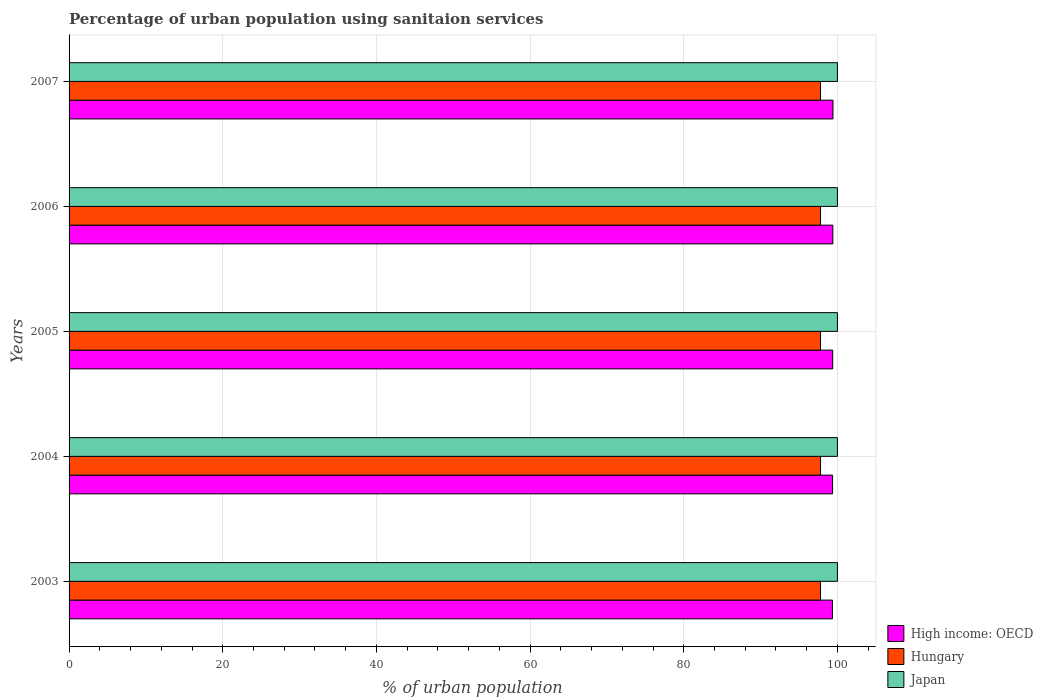How many different coloured bars are there?
Provide a succinct answer. 3. Are the number of bars per tick equal to the number of legend labels?
Make the answer very short. Yes. What is the percentage of urban population using sanitaion services in High income: OECD in 2003?
Make the answer very short. 99.35. Across all years, what is the maximum percentage of urban population using sanitaion services in Japan?
Your answer should be very brief. 100. Across all years, what is the minimum percentage of urban population using sanitaion services in Hungary?
Keep it short and to the point. 97.8. In which year was the percentage of urban population using sanitaion services in Japan minimum?
Offer a terse response. 2003. What is the total percentage of urban population using sanitaion services in Hungary in the graph?
Your answer should be compact. 489. What is the difference between the percentage of urban population using sanitaion services in Hungary in 2004 and the percentage of urban population using sanitaion services in Japan in 2003?
Offer a terse response. -2.2. In the year 2006, what is the difference between the percentage of urban population using sanitaion services in High income: OECD and percentage of urban population using sanitaion services in Hungary?
Provide a short and direct response. 1.6. Is the percentage of urban population using sanitaion services in High income: OECD in 2005 less than that in 2007?
Provide a short and direct response. Yes. What is the difference between the highest and the second highest percentage of urban population using sanitaion services in High income: OECD?
Offer a terse response. 0.02. What is the difference between the highest and the lowest percentage of urban population using sanitaion services in High income: OECD?
Your answer should be very brief. 0.07. In how many years, is the percentage of urban population using sanitaion services in Japan greater than the average percentage of urban population using sanitaion services in Japan taken over all years?
Offer a terse response. 0. What does the 2nd bar from the top in 2007 represents?
Your answer should be compact. Hungary. What does the 1st bar from the bottom in 2004 represents?
Offer a terse response. High income: OECD. Is it the case that in every year, the sum of the percentage of urban population using sanitaion services in High income: OECD and percentage of urban population using sanitaion services in Hungary is greater than the percentage of urban population using sanitaion services in Japan?
Provide a short and direct response. Yes. How many bars are there?
Offer a very short reply. 15. Are all the bars in the graph horizontal?
Your answer should be compact. Yes. Does the graph contain any zero values?
Your response must be concise. No. How many legend labels are there?
Your answer should be very brief. 3. What is the title of the graph?
Your response must be concise. Percentage of urban population using sanitaion services. Does "Belgium" appear as one of the legend labels in the graph?
Make the answer very short. No. What is the label or title of the X-axis?
Ensure brevity in your answer.  % of urban population. What is the label or title of the Y-axis?
Your answer should be very brief. Years. What is the % of urban population of High income: OECD in 2003?
Offer a terse response. 99.35. What is the % of urban population of Hungary in 2003?
Give a very brief answer. 97.8. What is the % of urban population in High income: OECD in 2004?
Give a very brief answer. 99.37. What is the % of urban population in Hungary in 2004?
Provide a succinct answer. 97.8. What is the % of urban population of Japan in 2004?
Offer a terse response. 100. What is the % of urban population in High income: OECD in 2005?
Provide a short and direct response. 99.39. What is the % of urban population of Hungary in 2005?
Offer a very short reply. 97.8. What is the % of urban population of Japan in 2005?
Keep it short and to the point. 100. What is the % of urban population of High income: OECD in 2006?
Offer a terse response. 99.4. What is the % of urban population in Hungary in 2006?
Your answer should be compact. 97.8. What is the % of urban population in High income: OECD in 2007?
Provide a succinct answer. 99.42. What is the % of urban population in Hungary in 2007?
Your answer should be very brief. 97.8. Across all years, what is the maximum % of urban population in High income: OECD?
Offer a terse response. 99.42. Across all years, what is the maximum % of urban population of Hungary?
Offer a terse response. 97.8. Across all years, what is the maximum % of urban population of Japan?
Your answer should be compact. 100. Across all years, what is the minimum % of urban population in High income: OECD?
Your answer should be very brief. 99.35. Across all years, what is the minimum % of urban population of Hungary?
Provide a succinct answer. 97.8. Across all years, what is the minimum % of urban population in Japan?
Your answer should be very brief. 100. What is the total % of urban population of High income: OECD in the graph?
Offer a terse response. 496.93. What is the total % of urban population of Hungary in the graph?
Provide a short and direct response. 489. What is the difference between the % of urban population in High income: OECD in 2003 and that in 2004?
Keep it short and to the point. -0.02. What is the difference between the % of urban population in High income: OECD in 2003 and that in 2005?
Your response must be concise. -0.04. What is the difference between the % of urban population of Hungary in 2003 and that in 2005?
Offer a terse response. 0. What is the difference between the % of urban population of High income: OECD in 2003 and that in 2006?
Your answer should be compact. -0.05. What is the difference between the % of urban population of Hungary in 2003 and that in 2006?
Offer a very short reply. 0. What is the difference between the % of urban population in High income: OECD in 2003 and that in 2007?
Keep it short and to the point. -0.07. What is the difference between the % of urban population in Hungary in 2003 and that in 2007?
Provide a short and direct response. 0. What is the difference between the % of urban population in Japan in 2003 and that in 2007?
Ensure brevity in your answer.  0. What is the difference between the % of urban population in High income: OECD in 2004 and that in 2005?
Provide a short and direct response. -0.02. What is the difference between the % of urban population of Hungary in 2004 and that in 2005?
Offer a very short reply. 0. What is the difference between the % of urban population in Japan in 2004 and that in 2005?
Your response must be concise. 0. What is the difference between the % of urban population in High income: OECD in 2004 and that in 2006?
Provide a succinct answer. -0.04. What is the difference between the % of urban population of Japan in 2004 and that in 2006?
Provide a succinct answer. 0. What is the difference between the % of urban population in High income: OECD in 2004 and that in 2007?
Keep it short and to the point. -0.05. What is the difference between the % of urban population in High income: OECD in 2005 and that in 2006?
Your answer should be very brief. -0.02. What is the difference between the % of urban population of Japan in 2005 and that in 2006?
Keep it short and to the point. 0. What is the difference between the % of urban population of High income: OECD in 2005 and that in 2007?
Ensure brevity in your answer.  -0.03. What is the difference between the % of urban population in Hungary in 2005 and that in 2007?
Offer a very short reply. 0. What is the difference between the % of urban population of High income: OECD in 2006 and that in 2007?
Make the answer very short. -0.02. What is the difference between the % of urban population in High income: OECD in 2003 and the % of urban population in Hungary in 2004?
Give a very brief answer. 1.55. What is the difference between the % of urban population of High income: OECD in 2003 and the % of urban population of Japan in 2004?
Give a very brief answer. -0.65. What is the difference between the % of urban population in Hungary in 2003 and the % of urban population in Japan in 2004?
Give a very brief answer. -2.2. What is the difference between the % of urban population of High income: OECD in 2003 and the % of urban population of Hungary in 2005?
Keep it short and to the point. 1.55. What is the difference between the % of urban population of High income: OECD in 2003 and the % of urban population of Japan in 2005?
Your answer should be very brief. -0.65. What is the difference between the % of urban population in Hungary in 2003 and the % of urban population in Japan in 2005?
Your response must be concise. -2.2. What is the difference between the % of urban population in High income: OECD in 2003 and the % of urban population in Hungary in 2006?
Your answer should be compact. 1.55. What is the difference between the % of urban population in High income: OECD in 2003 and the % of urban population in Japan in 2006?
Your answer should be very brief. -0.65. What is the difference between the % of urban population of Hungary in 2003 and the % of urban population of Japan in 2006?
Keep it short and to the point. -2.2. What is the difference between the % of urban population in High income: OECD in 2003 and the % of urban population in Hungary in 2007?
Keep it short and to the point. 1.55. What is the difference between the % of urban population of High income: OECD in 2003 and the % of urban population of Japan in 2007?
Offer a terse response. -0.65. What is the difference between the % of urban population of High income: OECD in 2004 and the % of urban population of Hungary in 2005?
Offer a very short reply. 1.57. What is the difference between the % of urban population of High income: OECD in 2004 and the % of urban population of Japan in 2005?
Provide a short and direct response. -0.63. What is the difference between the % of urban population in High income: OECD in 2004 and the % of urban population in Hungary in 2006?
Make the answer very short. 1.57. What is the difference between the % of urban population of High income: OECD in 2004 and the % of urban population of Japan in 2006?
Give a very brief answer. -0.63. What is the difference between the % of urban population in High income: OECD in 2004 and the % of urban population in Hungary in 2007?
Offer a very short reply. 1.57. What is the difference between the % of urban population of High income: OECD in 2004 and the % of urban population of Japan in 2007?
Your response must be concise. -0.63. What is the difference between the % of urban population of High income: OECD in 2005 and the % of urban population of Hungary in 2006?
Your answer should be compact. 1.59. What is the difference between the % of urban population in High income: OECD in 2005 and the % of urban population in Japan in 2006?
Give a very brief answer. -0.61. What is the difference between the % of urban population in Hungary in 2005 and the % of urban population in Japan in 2006?
Give a very brief answer. -2.2. What is the difference between the % of urban population in High income: OECD in 2005 and the % of urban population in Hungary in 2007?
Give a very brief answer. 1.59. What is the difference between the % of urban population in High income: OECD in 2005 and the % of urban population in Japan in 2007?
Your response must be concise. -0.61. What is the difference between the % of urban population of Hungary in 2005 and the % of urban population of Japan in 2007?
Your answer should be compact. -2.2. What is the difference between the % of urban population of High income: OECD in 2006 and the % of urban population of Hungary in 2007?
Ensure brevity in your answer.  1.6. What is the difference between the % of urban population in High income: OECD in 2006 and the % of urban population in Japan in 2007?
Offer a very short reply. -0.6. What is the difference between the % of urban population in Hungary in 2006 and the % of urban population in Japan in 2007?
Provide a succinct answer. -2.2. What is the average % of urban population in High income: OECD per year?
Your answer should be very brief. 99.39. What is the average % of urban population of Hungary per year?
Give a very brief answer. 97.8. In the year 2003, what is the difference between the % of urban population in High income: OECD and % of urban population in Hungary?
Your answer should be very brief. 1.55. In the year 2003, what is the difference between the % of urban population of High income: OECD and % of urban population of Japan?
Make the answer very short. -0.65. In the year 2004, what is the difference between the % of urban population of High income: OECD and % of urban population of Hungary?
Offer a very short reply. 1.57. In the year 2004, what is the difference between the % of urban population in High income: OECD and % of urban population in Japan?
Your response must be concise. -0.63. In the year 2005, what is the difference between the % of urban population of High income: OECD and % of urban population of Hungary?
Your answer should be very brief. 1.59. In the year 2005, what is the difference between the % of urban population of High income: OECD and % of urban population of Japan?
Offer a very short reply. -0.61. In the year 2006, what is the difference between the % of urban population of High income: OECD and % of urban population of Hungary?
Your response must be concise. 1.6. In the year 2006, what is the difference between the % of urban population of High income: OECD and % of urban population of Japan?
Offer a very short reply. -0.6. In the year 2006, what is the difference between the % of urban population in Hungary and % of urban population in Japan?
Keep it short and to the point. -2.2. In the year 2007, what is the difference between the % of urban population of High income: OECD and % of urban population of Hungary?
Your response must be concise. 1.62. In the year 2007, what is the difference between the % of urban population of High income: OECD and % of urban population of Japan?
Your answer should be very brief. -0.58. In the year 2007, what is the difference between the % of urban population in Hungary and % of urban population in Japan?
Offer a very short reply. -2.2. What is the ratio of the % of urban population in High income: OECD in 2003 to that in 2004?
Provide a short and direct response. 1. What is the ratio of the % of urban population of Japan in 2003 to that in 2005?
Provide a succinct answer. 1. What is the ratio of the % of urban population in Hungary in 2003 to that in 2006?
Make the answer very short. 1. What is the ratio of the % of urban population in High income: OECD in 2003 to that in 2007?
Ensure brevity in your answer.  1. What is the ratio of the % of urban population in Hungary in 2004 to that in 2005?
Ensure brevity in your answer.  1. What is the ratio of the % of urban population of Hungary in 2004 to that in 2006?
Your answer should be compact. 1. What is the ratio of the % of urban population of Japan in 2004 to that in 2006?
Your answer should be compact. 1. What is the ratio of the % of urban population in High income: OECD in 2004 to that in 2007?
Make the answer very short. 1. What is the ratio of the % of urban population of Hungary in 2004 to that in 2007?
Your answer should be compact. 1. What is the ratio of the % of urban population in Japan in 2004 to that in 2007?
Give a very brief answer. 1. What is the ratio of the % of urban population in High income: OECD in 2005 to that in 2006?
Provide a succinct answer. 1. What is the ratio of the % of urban population of Hungary in 2005 to that in 2007?
Your response must be concise. 1. What is the ratio of the % of urban population of Japan in 2005 to that in 2007?
Make the answer very short. 1. What is the ratio of the % of urban population in High income: OECD in 2006 to that in 2007?
Keep it short and to the point. 1. What is the ratio of the % of urban population in Hungary in 2006 to that in 2007?
Provide a succinct answer. 1. What is the ratio of the % of urban population in Japan in 2006 to that in 2007?
Make the answer very short. 1. What is the difference between the highest and the second highest % of urban population of High income: OECD?
Your answer should be very brief. 0.02. What is the difference between the highest and the second highest % of urban population of Hungary?
Ensure brevity in your answer.  0. What is the difference between the highest and the second highest % of urban population of Japan?
Offer a terse response. 0. What is the difference between the highest and the lowest % of urban population in High income: OECD?
Your response must be concise. 0.07. What is the difference between the highest and the lowest % of urban population of Hungary?
Your answer should be compact. 0. What is the difference between the highest and the lowest % of urban population in Japan?
Your answer should be compact. 0. 